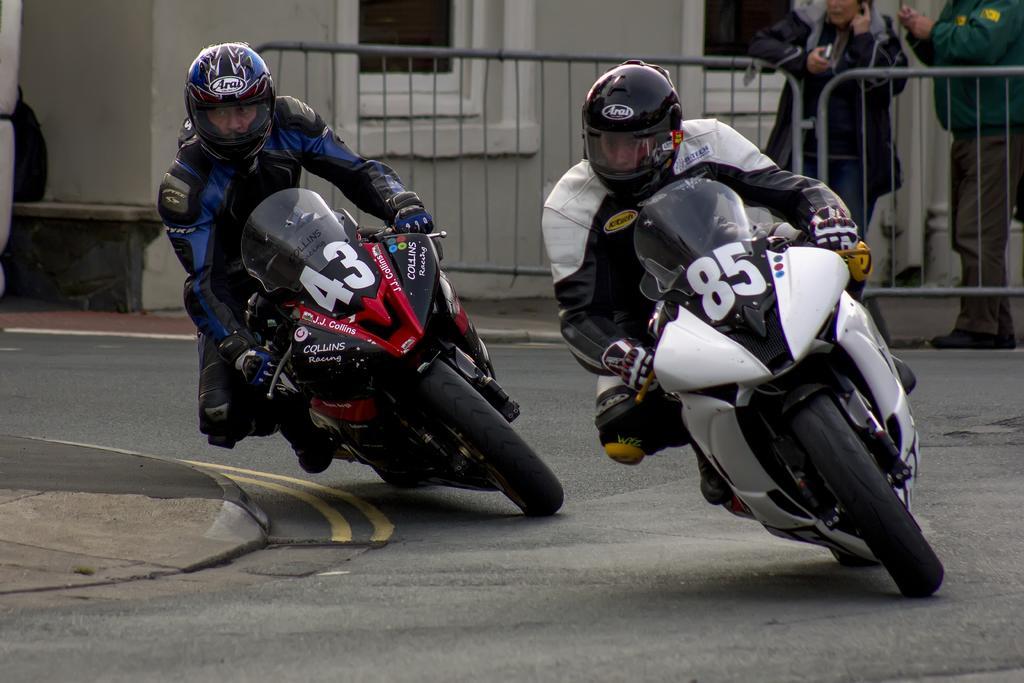Can you describe this image briefly? In this image we can see two persons are participating in a bike race and riding bikes. On the top right side, we can see two persons are standing. 